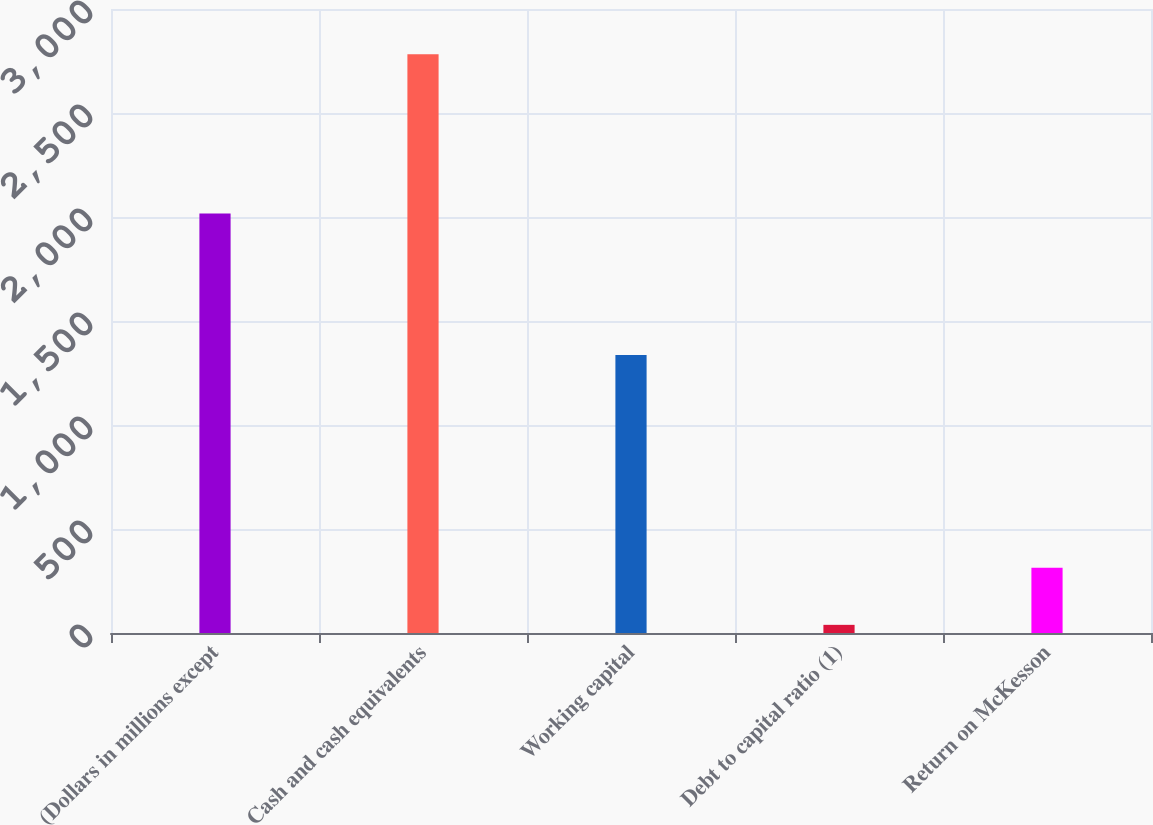<chart> <loc_0><loc_0><loc_500><loc_500><bar_chart><fcel>(Dollars in millions except<fcel>Cash and cash equivalents<fcel>Working capital<fcel>Debt to capital ratio (1)<fcel>Return on McKesson<nl><fcel>2017<fcel>2783<fcel>1336<fcel>39.2<fcel>313.58<nl></chart> 